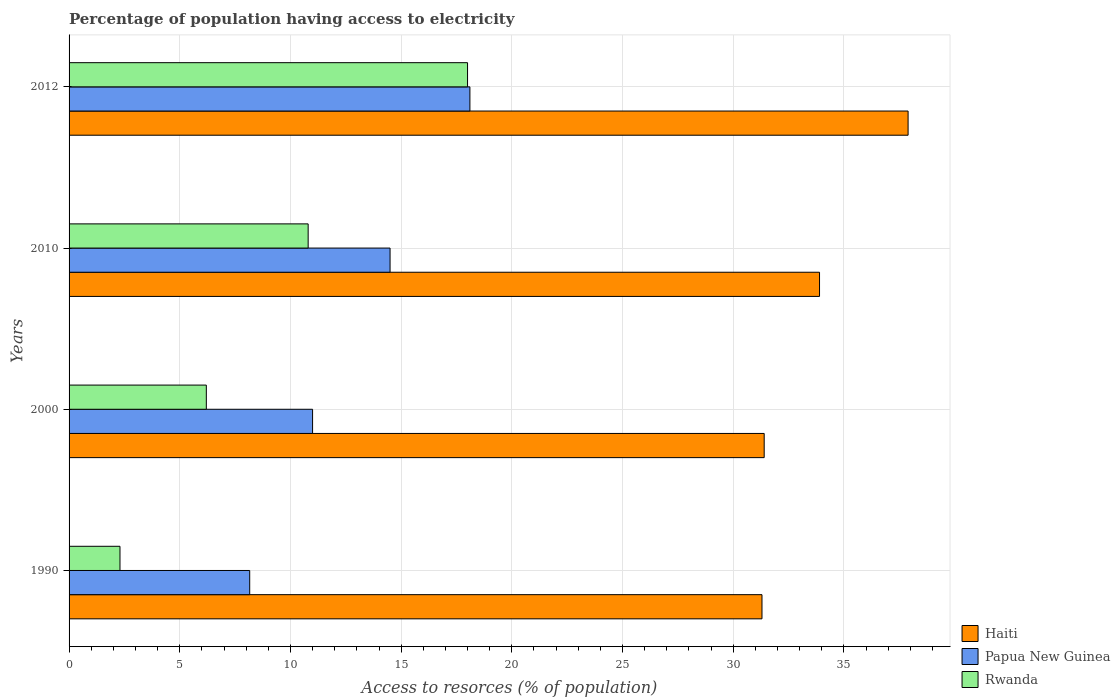How many bars are there on the 2nd tick from the top?
Your answer should be very brief. 3. How many bars are there on the 4th tick from the bottom?
Offer a terse response. 3. What is the label of the 3rd group of bars from the top?
Offer a very short reply. 2000. In how many cases, is the number of bars for a given year not equal to the number of legend labels?
Provide a short and direct response. 0. What is the percentage of population having access to electricity in Rwanda in 2010?
Your answer should be compact. 10.8. In which year was the percentage of population having access to electricity in Haiti maximum?
Ensure brevity in your answer.  2012. In which year was the percentage of population having access to electricity in Papua New Guinea minimum?
Give a very brief answer. 1990. What is the total percentage of population having access to electricity in Rwanda in the graph?
Provide a succinct answer. 37.3. What is the difference between the percentage of population having access to electricity in Rwanda in 2010 and that in 2012?
Keep it short and to the point. -7.2. What is the difference between the percentage of population having access to electricity in Haiti in 2010 and the percentage of population having access to electricity in Papua New Guinea in 2000?
Keep it short and to the point. 22.9. What is the average percentage of population having access to electricity in Papua New Guinea per year?
Your answer should be very brief. 12.94. In how many years, is the percentage of population having access to electricity in Papua New Guinea greater than 5 %?
Make the answer very short. 4. What is the ratio of the percentage of population having access to electricity in Rwanda in 2000 to that in 2012?
Offer a very short reply. 0.34. What is the difference between the highest and the second highest percentage of population having access to electricity in Papua New Guinea?
Give a very brief answer. 3.61. What is the difference between the highest and the lowest percentage of population having access to electricity in Haiti?
Your answer should be very brief. 6.6. In how many years, is the percentage of population having access to electricity in Papua New Guinea greater than the average percentage of population having access to electricity in Papua New Guinea taken over all years?
Provide a short and direct response. 2. What does the 1st bar from the top in 2010 represents?
Make the answer very short. Rwanda. What does the 2nd bar from the bottom in 1990 represents?
Make the answer very short. Papua New Guinea. Are all the bars in the graph horizontal?
Keep it short and to the point. Yes. What is the difference between two consecutive major ticks on the X-axis?
Give a very brief answer. 5. Does the graph contain any zero values?
Offer a terse response. No. Where does the legend appear in the graph?
Provide a succinct answer. Bottom right. How many legend labels are there?
Offer a terse response. 3. What is the title of the graph?
Provide a short and direct response. Percentage of population having access to electricity. Does "East Asia (developing only)" appear as one of the legend labels in the graph?
Give a very brief answer. No. What is the label or title of the X-axis?
Your answer should be very brief. Access to resorces (% of population). What is the Access to resorces (% of population) of Haiti in 1990?
Keep it short and to the point. 31.3. What is the Access to resorces (% of population) of Papua New Guinea in 1990?
Offer a terse response. 8.16. What is the Access to resorces (% of population) of Haiti in 2000?
Provide a short and direct response. 31.4. What is the Access to resorces (% of population) of Haiti in 2010?
Make the answer very short. 33.9. What is the Access to resorces (% of population) of Haiti in 2012?
Offer a terse response. 37.9. What is the Access to resorces (% of population) in Papua New Guinea in 2012?
Your answer should be very brief. 18.11. What is the Access to resorces (% of population) of Rwanda in 2012?
Offer a terse response. 18. Across all years, what is the maximum Access to resorces (% of population) of Haiti?
Your answer should be very brief. 37.9. Across all years, what is the maximum Access to resorces (% of population) of Papua New Guinea?
Keep it short and to the point. 18.11. Across all years, what is the maximum Access to resorces (% of population) in Rwanda?
Your answer should be very brief. 18. Across all years, what is the minimum Access to resorces (% of population) in Haiti?
Provide a succinct answer. 31.3. Across all years, what is the minimum Access to resorces (% of population) in Papua New Guinea?
Your answer should be very brief. 8.16. What is the total Access to resorces (% of population) of Haiti in the graph?
Keep it short and to the point. 134.5. What is the total Access to resorces (% of population) in Papua New Guinea in the graph?
Your answer should be compact. 51.77. What is the total Access to resorces (% of population) in Rwanda in the graph?
Make the answer very short. 37.3. What is the difference between the Access to resorces (% of population) in Papua New Guinea in 1990 and that in 2000?
Provide a short and direct response. -2.84. What is the difference between the Access to resorces (% of population) in Haiti in 1990 and that in 2010?
Your answer should be compact. -2.6. What is the difference between the Access to resorces (% of population) of Papua New Guinea in 1990 and that in 2010?
Provide a succinct answer. -6.34. What is the difference between the Access to resorces (% of population) in Rwanda in 1990 and that in 2010?
Ensure brevity in your answer.  -8.5. What is the difference between the Access to resorces (% of population) of Haiti in 1990 and that in 2012?
Give a very brief answer. -6.6. What is the difference between the Access to resorces (% of population) in Papua New Guinea in 1990 and that in 2012?
Provide a short and direct response. -9.95. What is the difference between the Access to resorces (% of population) in Rwanda in 1990 and that in 2012?
Your response must be concise. -15.7. What is the difference between the Access to resorces (% of population) of Papua New Guinea in 2000 and that in 2010?
Ensure brevity in your answer.  -3.5. What is the difference between the Access to resorces (% of population) of Rwanda in 2000 and that in 2010?
Your answer should be very brief. -4.6. What is the difference between the Access to resorces (% of population) in Haiti in 2000 and that in 2012?
Provide a short and direct response. -6.5. What is the difference between the Access to resorces (% of population) of Papua New Guinea in 2000 and that in 2012?
Offer a terse response. -7.11. What is the difference between the Access to resorces (% of population) of Papua New Guinea in 2010 and that in 2012?
Ensure brevity in your answer.  -3.61. What is the difference between the Access to resorces (% of population) of Haiti in 1990 and the Access to resorces (% of population) of Papua New Guinea in 2000?
Give a very brief answer. 20.3. What is the difference between the Access to resorces (% of population) in Haiti in 1990 and the Access to resorces (% of population) in Rwanda in 2000?
Your answer should be compact. 25.1. What is the difference between the Access to resorces (% of population) in Papua New Guinea in 1990 and the Access to resorces (% of population) in Rwanda in 2000?
Ensure brevity in your answer.  1.96. What is the difference between the Access to resorces (% of population) of Haiti in 1990 and the Access to resorces (% of population) of Rwanda in 2010?
Your answer should be very brief. 20.5. What is the difference between the Access to resorces (% of population) of Papua New Guinea in 1990 and the Access to resorces (% of population) of Rwanda in 2010?
Ensure brevity in your answer.  -2.64. What is the difference between the Access to resorces (% of population) in Haiti in 1990 and the Access to resorces (% of population) in Papua New Guinea in 2012?
Your response must be concise. 13.19. What is the difference between the Access to resorces (% of population) of Haiti in 1990 and the Access to resorces (% of population) of Rwanda in 2012?
Make the answer very short. 13.3. What is the difference between the Access to resorces (% of population) of Papua New Guinea in 1990 and the Access to resorces (% of population) of Rwanda in 2012?
Your response must be concise. -9.84. What is the difference between the Access to resorces (% of population) of Haiti in 2000 and the Access to resorces (% of population) of Rwanda in 2010?
Give a very brief answer. 20.6. What is the difference between the Access to resorces (% of population) of Haiti in 2000 and the Access to resorces (% of population) of Papua New Guinea in 2012?
Give a very brief answer. 13.29. What is the difference between the Access to resorces (% of population) of Haiti in 2010 and the Access to resorces (% of population) of Papua New Guinea in 2012?
Your answer should be very brief. 15.79. What is the average Access to resorces (% of population) of Haiti per year?
Your answer should be very brief. 33.62. What is the average Access to resorces (% of population) of Papua New Guinea per year?
Offer a very short reply. 12.94. What is the average Access to resorces (% of population) of Rwanda per year?
Offer a terse response. 9.32. In the year 1990, what is the difference between the Access to resorces (% of population) in Haiti and Access to resorces (% of population) in Papua New Guinea?
Give a very brief answer. 23.14. In the year 1990, what is the difference between the Access to resorces (% of population) of Papua New Guinea and Access to resorces (% of population) of Rwanda?
Your response must be concise. 5.86. In the year 2000, what is the difference between the Access to resorces (% of population) of Haiti and Access to resorces (% of population) of Papua New Guinea?
Your response must be concise. 20.4. In the year 2000, what is the difference between the Access to resorces (% of population) of Haiti and Access to resorces (% of population) of Rwanda?
Your answer should be very brief. 25.2. In the year 2000, what is the difference between the Access to resorces (% of population) of Papua New Guinea and Access to resorces (% of population) of Rwanda?
Give a very brief answer. 4.8. In the year 2010, what is the difference between the Access to resorces (% of population) in Haiti and Access to resorces (% of population) in Papua New Guinea?
Your response must be concise. 19.4. In the year 2010, what is the difference between the Access to resorces (% of population) in Haiti and Access to resorces (% of population) in Rwanda?
Provide a short and direct response. 23.1. In the year 2010, what is the difference between the Access to resorces (% of population) in Papua New Guinea and Access to resorces (% of population) in Rwanda?
Ensure brevity in your answer.  3.7. In the year 2012, what is the difference between the Access to resorces (% of population) in Haiti and Access to resorces (% of population) in Papua New Guinea?
Offer a terse response. 19.79. In the year 2012, what is the difference between the Access to resorces (% of population) in Papua New Guinea and Access to resorces (% of population) in Rwanda?
Your answer should be compact. 0.11. What is the ratio of the Access to resorces (% of population) in Papua New Guinea in 1990 to that in 2000?
Ensure brevity in your answer.  0.74. What is the ratio of the Access to resorces (% of population) of Rwanda in 1990 to that in 2000?
Make the answer very short. 0.37. What is the ratio of the Access to resorces (% of population) of Haiti in 1990 to that in 2010?
Offer a terse response. 0.92. What is the ratio of the Access to resorces (% of population) of Papua New Guinea in 1990 to that in 2010?
Ensure brevity in your answer.  0.56. What is the ratio of the Access to resorces (% of population) of Rwanda in 1990 to that in 2010?
Give a very brief answer. 0.21. What is the ratio of the Access to resorces (% of population) of Haiti in 1990 to that in 2012?
Offer a very short reply. 0.83. What is the ratio of the Access to resorces (% of population) in Papua New Guinea in 1990 to that in 2012?
Offer a very short reply. 0.45. What is the ratio of the Access to resorces (% of population) of Rwanda in 1990 to that in 2012?
Your answer should be very brief. 0.13. What is the ratio of the Access to resorces (% of population) in Haiti in 2000 to that in 2010?
Keep it short and to the point. 0.93. What is the ratio of the Access to resorces (% of population) in Papua New Guinea in 2000 to that in 2010?
Provide a succinct answer. 0.76. What is the ratio of the Access to resorces (% of population) of Rwanda in 2000 to that in 2010?
Offer a terse response. 0.57. What is the ratio of the Access to resorces (% of population) in Haiti in 2000 to that in 2012?
Make the answer very short. 0.83. What is the ratio of the Access to resorces (% of population) in Papua New Guinea in 2000 to that in 2012?
Your answer should be very brief. 0.61. What is the ratio of the Access to resorces (% of population) of Rwanda in 2000 to that in 2012?
Offer a terse response. 0.34. What is the ratio of the Access to resorces (% of population) of Haiti in 2010 to that in 2012?
Ensure brevity in your answer.  0.89. What is the ratio of the Access to resorces (% of population) in Papua New Guinea in 2010 to that in 2012?
Offer a terse response. 0.8. What is the ratio of the Access to resorces (% of population) in Rwanda in 2010 to that in 2012?
Provide a short and direct response. 0.6. What is the difference between the highest and the second highest Access to resorces (% of population) in Papua New Guinea?
Offer a terse response. 3.61. What is the difference between the highest and the lowest Access to resorces (% of population) in Haiti?
Make the answer very short. 6.6. What is the difference between the highest and the lowest Access to resorces (% of population) in Papua New Guinea?
Your answer should be compact. 9.95. What is the difference between the highest and the lowest Access to resorces (% of population) in Rwanda?
Keep it short and to the point. 15.7. 